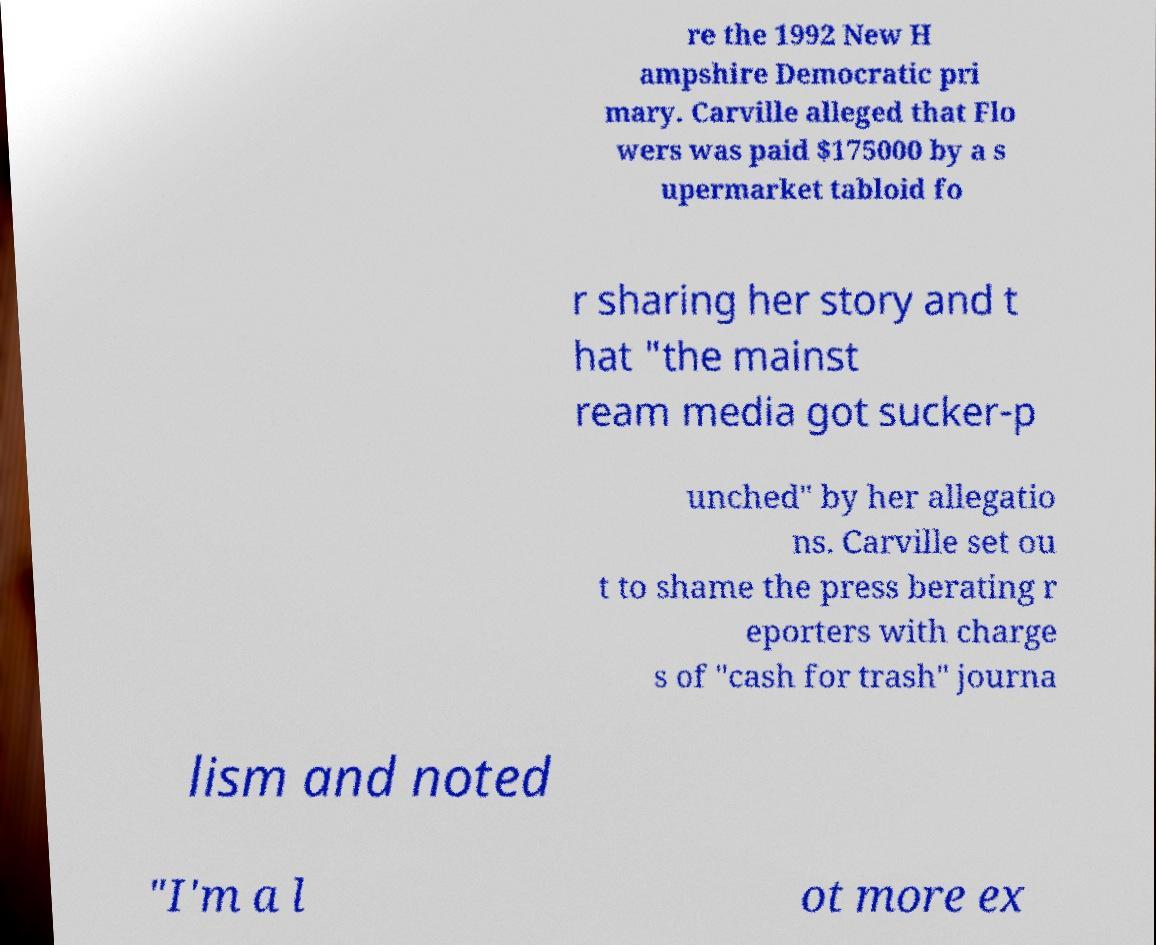Please read and relay the text visible in this image. What does it say? re the 1992 New H ampshire Democratic pri mary. Carville alleged that Flo wers was paid $175000 by a s upermarket tabloid fo r sharing her story and t hat "the mainst ream media got sucker-p unched" by her allegatio ns. Carville set ou t to shame the press berating r eporters with charge s of "cash for trash" journa lism and noted "I'm a l ot more ex 